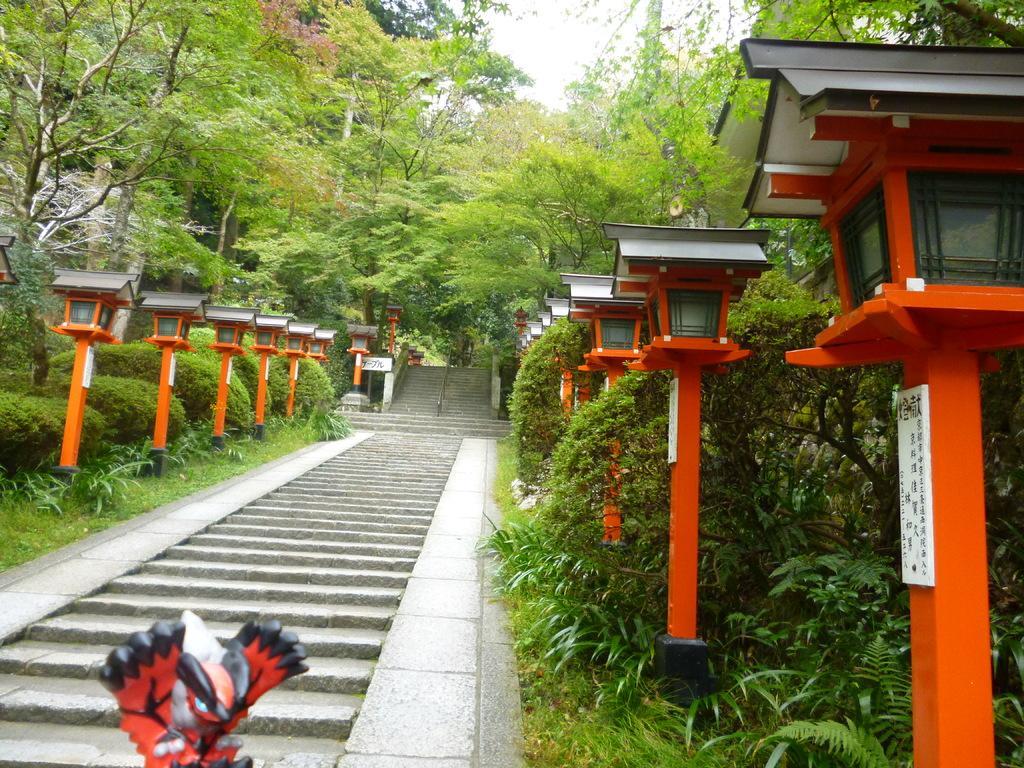How would you summarize this image in a sentence or two? In this image we can see some poles, lights, plants, trees, grass and staircases, also we can see a sculpture in the background we can see the sky. 